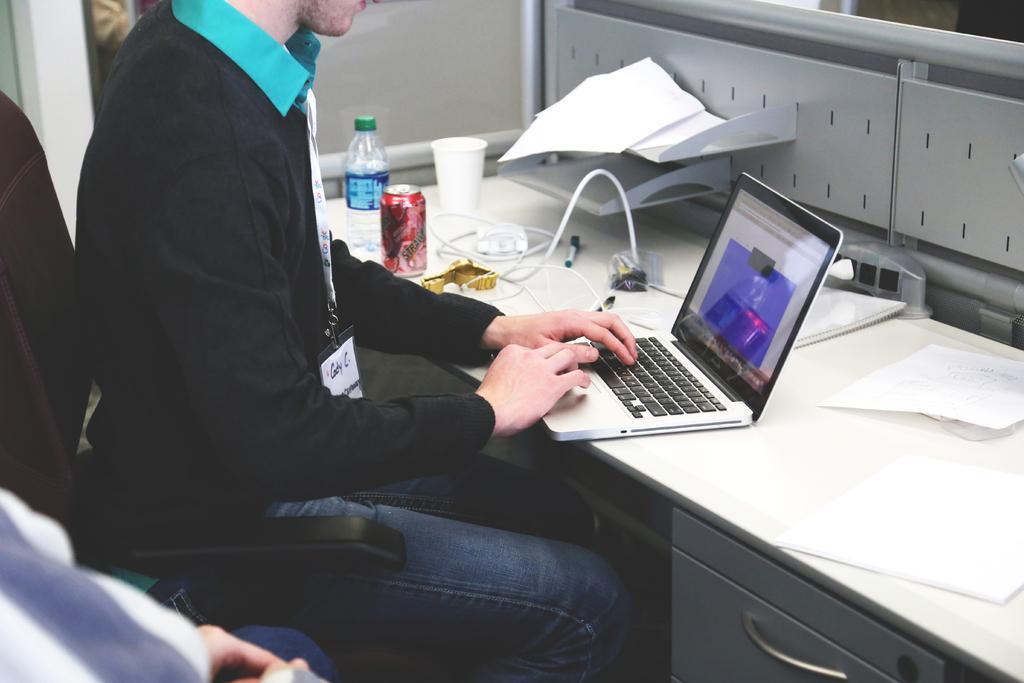Could you give a brief overview of what you see in this image? In this picture we can see a man and he is sitting on a chair, beside him we can see a person, here we can see a table, laptop, bottle, coke tin, glass, pen, papers and some objects. 